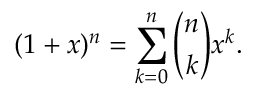<formula> <loc_0><loc_0><loc_500><loc_500>( 1 + x ) ^ { n } = \sum _ { k = 0 } ^ { n } { \binom { n } { k } } x ^ { k } .</formula> 